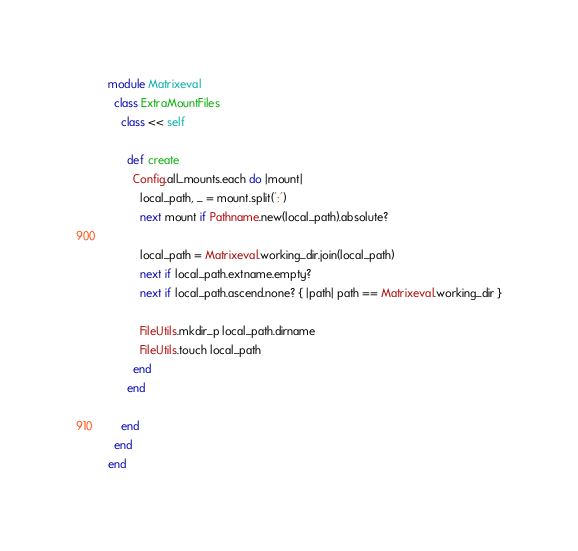Convert code to text. <code><loc_0><loc_0><loc_500><loc_500><_Ruby_>module Matrixeval
  class ExtraMountFiles
    class << self

      def create
        Config.all_mounts.each do |mount|
          local_path, _ = mount.split(':')
          next mount if Pathname.new(local_path).absolute?

          local_path = Matrixeval.working_dir.join(local_path)
          next if local_path.extname.empty?
          next if local_path.ascend.none? { |path| path == Matrixeval.working_dir }

          FileUtils.mkdir_p local_path.dirname
          FileUtils.touch local_path
        end
      end

    end
  end
end
</code> 